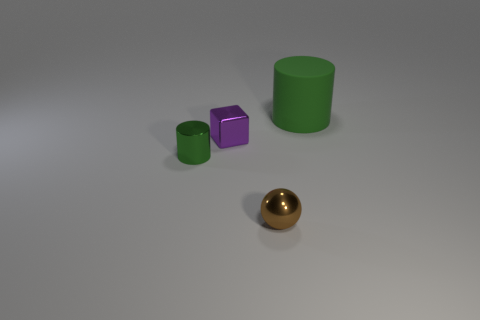What number of other things are there of the same material as the large green cylinder
Offer a terse response. 0. What material is the cylinder that is the same size as the purple metallic cube?
Keep it short and to the point. Metal. Is the number of things that are on the right side of the small cylinder less than the number of things?
Provide a succinct answer. Yes. What is the shape of the small thing in front of the cylinder on the left side of the green thing that is on the right side of the metallic block?
Provide a short and direct response. Sphere. How big is the green thing behind the small metallic block?
Give a very brief answer. Large. There is a purple thing that is the same size as the metal cylinder; what shape is it?
Keep it short and to the point. Cube. What number of objects are either yellow things or objects to the right of the block?
Your response must be concise. 2. There is a tiny object that is to the left of the purple cube that is on the right side of the green metal cylinder; what number of big matte cylinders are to the left of it?
Keep it short and to the point. 0. What color is the cylinder that is made of the same material as the ball?
Your answer should be very brief. Green. There is a green object that is in front of the matte thing; is it the same size as the purple metal block?
Offer a terse response. Yes. 